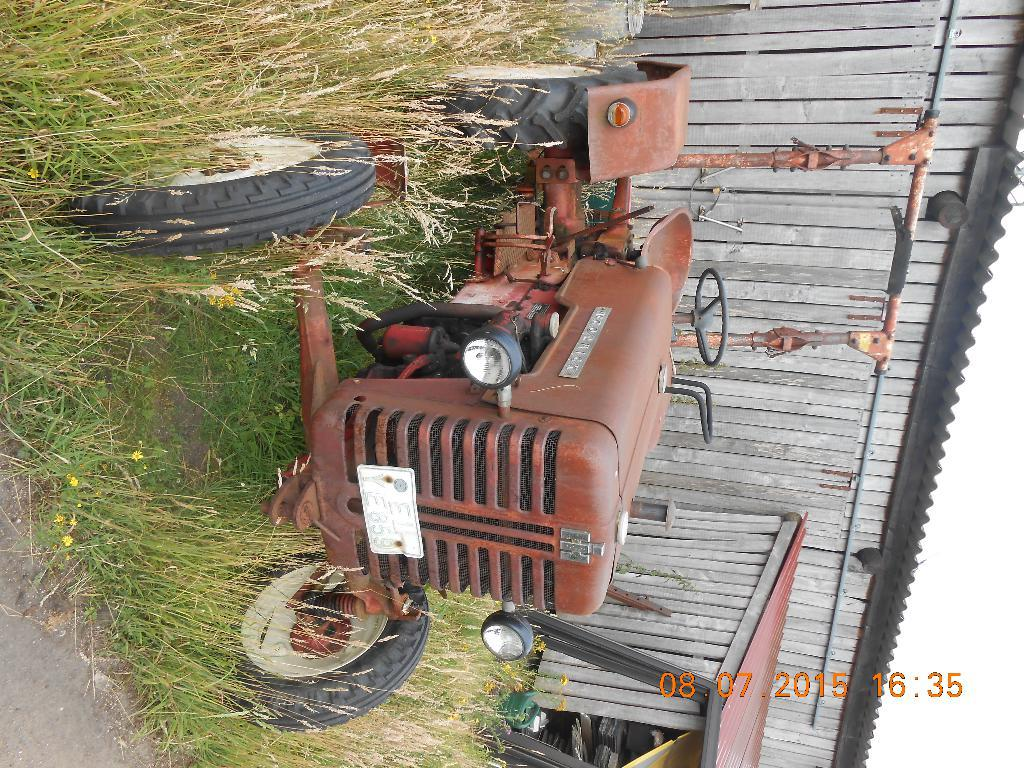How is the image oriented? The image is tilted. What type of vehicle can be seen in the image? There is a tractor in the image. What type of structure is present in the image? There is a shed in the image. What type of vegetation is visible in the image? There are plants in the image. What additional information is provided in the bottom right corner of the image? The date and time are visible in the bottom right corner of the image. What type of bomb can be seen exploding in the image? There is no bomb or explosion present in the image; it features a tractor, shed, plants, and a tilted orientation. What type of rhythm is being played by the plants in the image? There is no rhythm or music being played by the plants in the image; they are simply vegetation. 